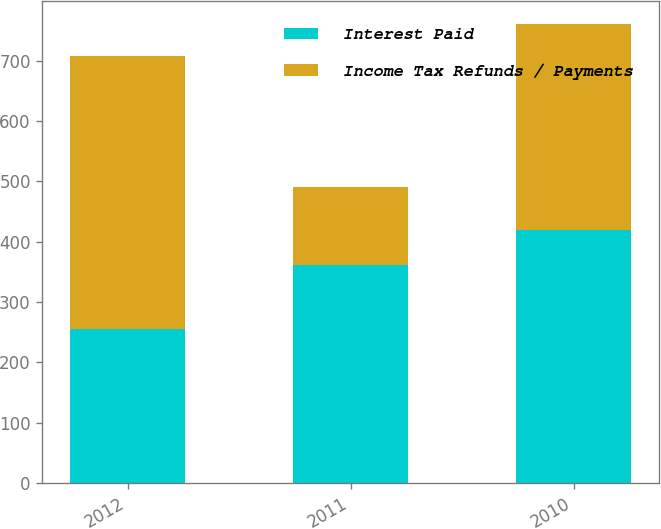Convert chart. <chart><loc_0><loc_0><loc_500><loc_500><stacked_bar_chart><ecel><fcel>2012<fcel>2011<fcel>2010<nl><fcel>Interest Paid<fcel>255<fcel>361<fcel>419<nl><fcel>Income Tax Refunds / Payments<fcel>453<fcel>130<fcel>342<nl></chart> 